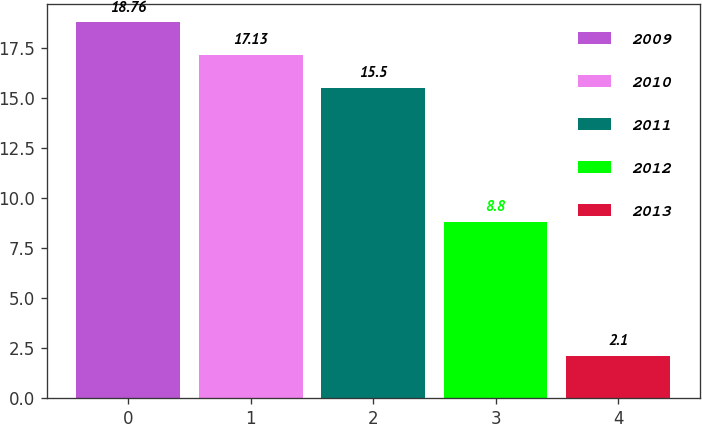Convert chart to OTSL. <chart><loc_0><loc_0><loc_500><loc_500><bar_chart><fcel>2009<fcel>2010<fcel>2011<fcel>2012<fcel>2013<nl><fcel>18.76<fcel>17.13<fcel>15.5<fcel>8.8<fcel>2.1<nl></chart> 